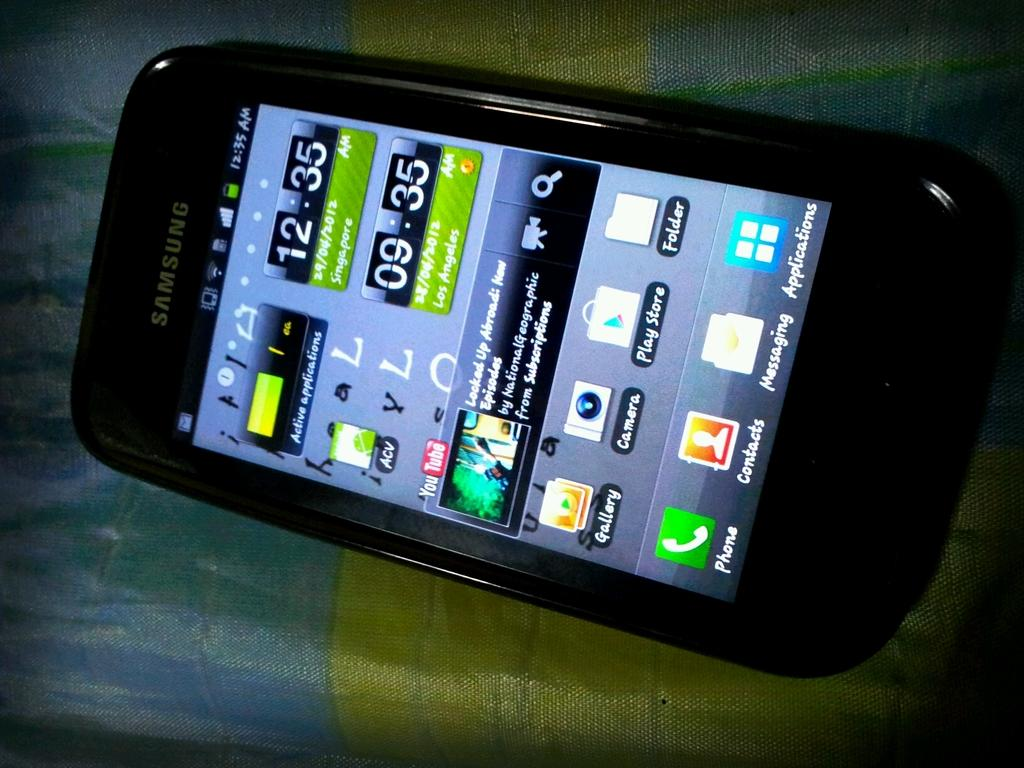<image>
Relay a brief, clear account of the picture shown. A samsung smartphone showing the time of Singapore at 12:35 am and Los Angeles with the time being 09:35 am 